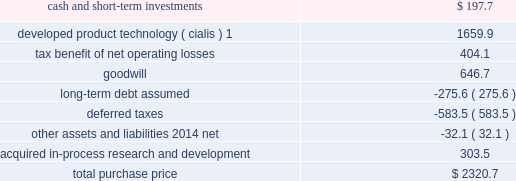Icos corporation on january 29 , 2007 , we acquired all of the outstanding common stock of icos corporation ( icos ) , our partner in the lilly icos llc joint venture for the manufacture and sale of cialis for the treatment of erectile dysfunction .
The acquisition brought the full value of cialis to us and enabled us to realize operational effi ciencies in the further development , marketing , and selling of this product .
The aggregate cash purchase price of approximately $ 2.3 bil- lion was fi nanced through borrowings .
The acquisition has been accounted for as a business combination under the purchase method of accounting , resulting in goodwill of $ 646.7 million .
No portion of this goodwill was deductible for tax purposes .
We determined the following estimated fair values for the assets acquired and liabilities assumed as of the date of acquisition .
Estimated fair value at january 29 , 2007 .
1this intangible asset will be amortized over the remaining expected patent lives of cialis in each country ; patent expiry dates range from 2015 to 2017 .
New indications for and formulations of the cialis compound in clinical testing at the time of the acquisition represented approximately 48 percent of the estimated fair value of the acquired ipr&d .
The remaining value of acquired ipr&d represented several other products in development , with no one asset comprising a signifi cant por- tion of this value .
The discount rate we used in valuing the acquired ipr&d projects was 20 percent , and the charge for acquired ipr&d of $ 303.5 million recorded in the fi rst quarter of 2007 was not deductible for tax purposes .
Other acquisitions during the second quarter of 2007 , we acquired all of the outstanding stock of both hypnion , inc .
( hypnion ) , a privately held neuroscience drug discovery company focused on sleep disorders , and ivy animal health , inc .
( ivy ) , a privately held applied research and pharmaceutical product development company focused on the animal health industry , for $ 445.0 million in cash .
The acquisition of hypnion provided us with a broader and more substantive presence in the area of sleep disorder research and ownership of hy10275 , a novel phase ii compound with a dual mechanism of action aimed at promoting better sleep onset and sleep maintenance .
This was hypnion 2019s only signifi cant asset .
For this acquisi- tion , we recorded an acquired ipr&d charge of $ 291.1 million , which was not deductible for tax purposes .
Because hypnion was a development-stage company , the transaction was accounted for as an acquisition of assets rather than as a business combination and , therefore , goodwill was not recorded .
The acquisition of ivy provides us with products that complement those of our animal health business .
This acquisition has been accounted for as a business combination under the purchase method of accounting .
We allocated $ 88.7 million of the purchase price to other identifi able intangible assets , primarily related to marketed products , $ 37.0 million to acquired ipr&d , and $ 25.0 million to goodwill .
The other identifi able intangible assets are being amortized over their estimated remaining useful lives of 10 to 20 years .
The $ 37.0 million allocated to acquired ipr&d was charged to expense in the second quarter of 2007 .
Goodwill resulting from this acquisition was fully allocated to the animal health business segment .
The amount allocated to each of the intangible assets acquired , including goodwill of $ 25.0 million and the acquired ipr&d of $ 37.0 million , was deductible for tax purposes .
Product acquisitions in june 2008 , we entered into a licensing and development agreement with transpharma medical ltd .
( trans- pharma ) to acquire rights to its product and related drug delivery system for the treatment of osteoporosis .
The product , which is administered transdermally using transpharma 2019s proprietary technology , was in phase ii clinical testing , and had no alternative future use .
Under the arrangement , we also gained non-exclusive access to trans- pharma 2019s viaderm drug delivery system for the product .
As with many development-phase products , launch of the .
What percentage of the total purchase price was comprised of goodwill? 
Computations: (646.7 / 2320.7)
Answer: 0.27867. 